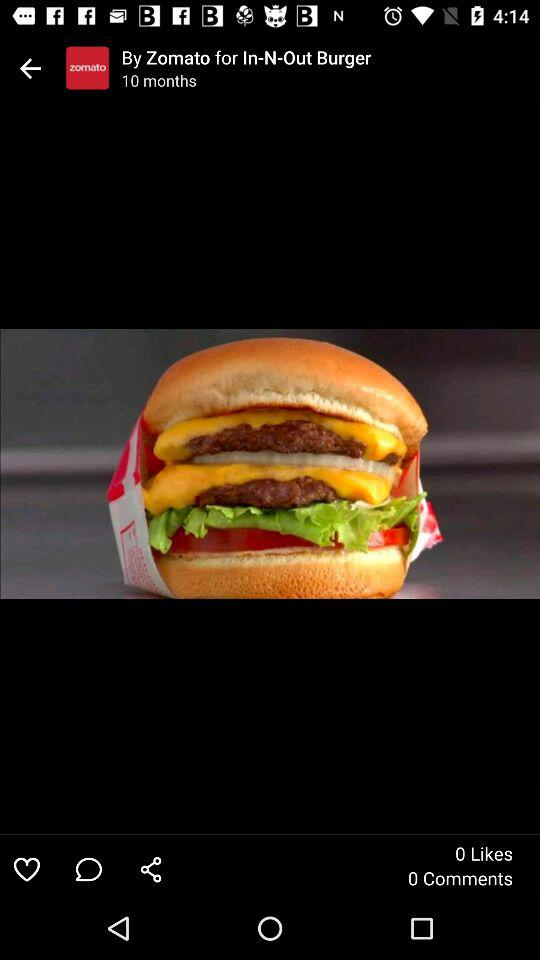What is the title of the photograph? The title is "In-N-Out Burger". 